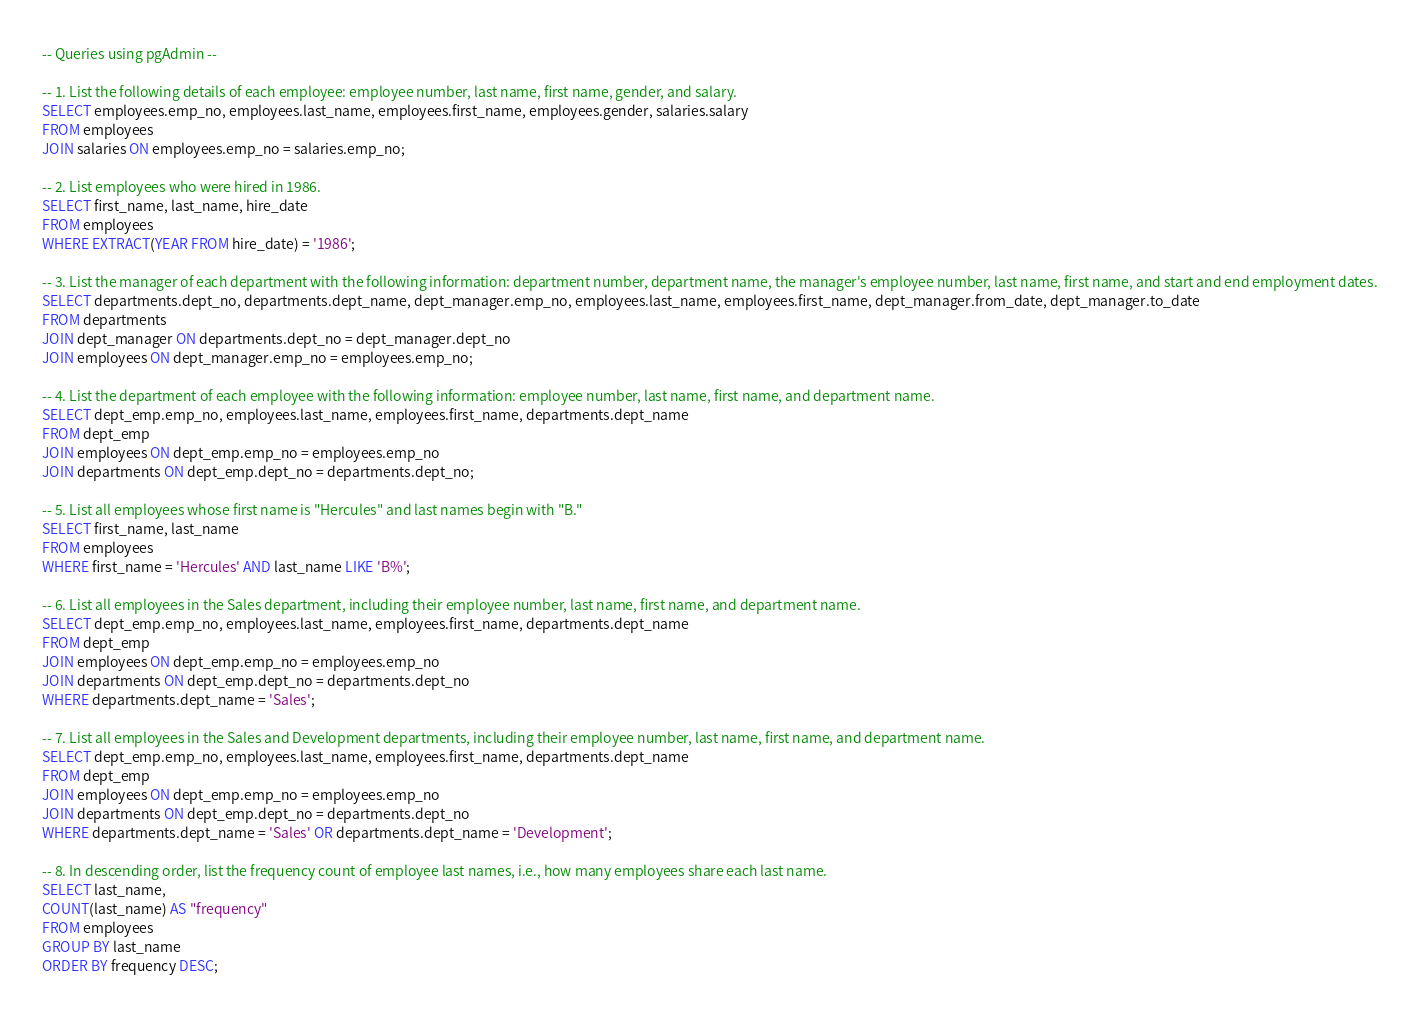<code> <loc_0><loc_0><loc_500><loc_500><_SQL_>-- Queries using pgAdmin --

-- 1. List the following details of each employee: employee number, last name, first name, gender, and salary.
SELECT employees.emp_no, employees.last_name, employees.first_name, employees.gender, salaries.salary
FROM employees
JOIN salaries ON employees.emp_no = salaries.emp_no;

-- 2. List employees who were hired in 1986.
SELECT first_name, last_name, hire_date 
FROM employees
WHERE EXTRACT(YEAR FROM hire_date) = '1986';

-- 3. List the manager of each department with the following information: department number, department name, the manager's employee number, last name, first name, and start and end employment dates.
SELECT departments.dept_no, departments.dept_name, dept_manager.emp_no, employees.last_name, employees.first_name, dept_manager.from_date, dept_manager.to_date
FROM departments
JOIN dept_manager ON departments.dept_no = dept_manager.dept_no
JOIN employees ON dept_manager.emp_no = employees.emp_no;

-- 4. List the department of each employee with the following information: employee number, last name, first name, and department name.
SELECT dept_emp.emp_no, employees.last_name, employees.first_name, departments.dept_name
FROM dept_emp
JOIN employees ON dept_emp.emp_no = employees.emp_no
JOIN departments ON dept_emp.dept_no = departments.dept_no;

-- 5. List all employees whose first name is "Hercules" and last names begin with "B."
SELECT first_name, last_name
FROM employees
WHERE first_name = 'Hercules' AND last_name LIKE 'B%';

-- 6. List all employees in the Sales department, including their employee number, last name, first name, and department name.
SELECT dept_emp.emp_no, employees.last_name, employees.first_name, departments.dept_name
FROM dept_emp
JOIN employees ON dept_emp.emp_no = employees.emp_no
JOIN departments ON dept_emp.dept_no = departments.dept_no
WHERE departments.dept_name = 'Sales';

-- 7. List all employees in the Sales and Development departments, including their employee number, last name, first name, and department name.
SELECT dept_emp.emp_no, employees.last_name, employees.first_name, departments.dept_name
FROM dept_emp
JOIN employees ON dept_emp.emp_no = employees.emp_no
JOIN departments ON dept_emp.dept_no = departments.dept_no
WHERE departments.dept_name = 'Sales' OR departments.dept_name = 'Development';

-- 8. In descending order, list the frequency count of employee last names, i.e., how many employees share each last name.
SELECT last_name,
COUNT(last_name) AS "frequency"
FROM employees
GROUP BY last_name
ORDER BY frequency DESC;
</code> 